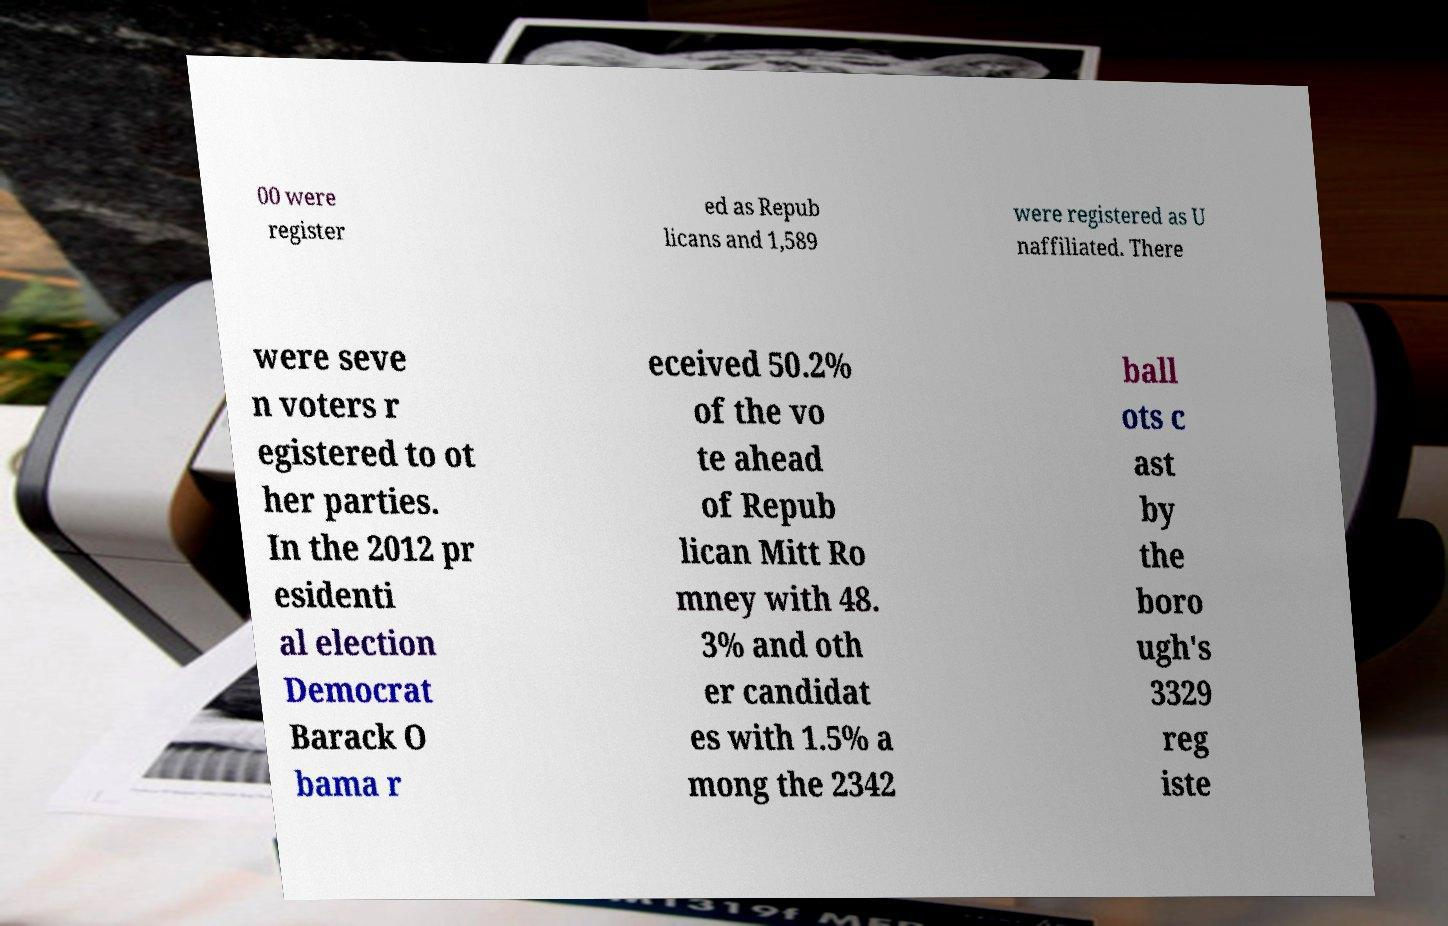There's text embedded in this image that I need extracted. Can you transcribe it verbatim? 00 were register ed as Repub licans and 1,589 were registered as U naffiliated. There were seve n voters r egistered to ot her parties. In the 2012 pr esidenti al election Democrat Barack O bama r eceived 50.2% of the vo te ahead of Repub lican Mitt Ro mney with 48. 3% and oth er candidat es with 1.5% a mong the 2342 ball ots c ast by the boro ugh's 3329 reg iste 